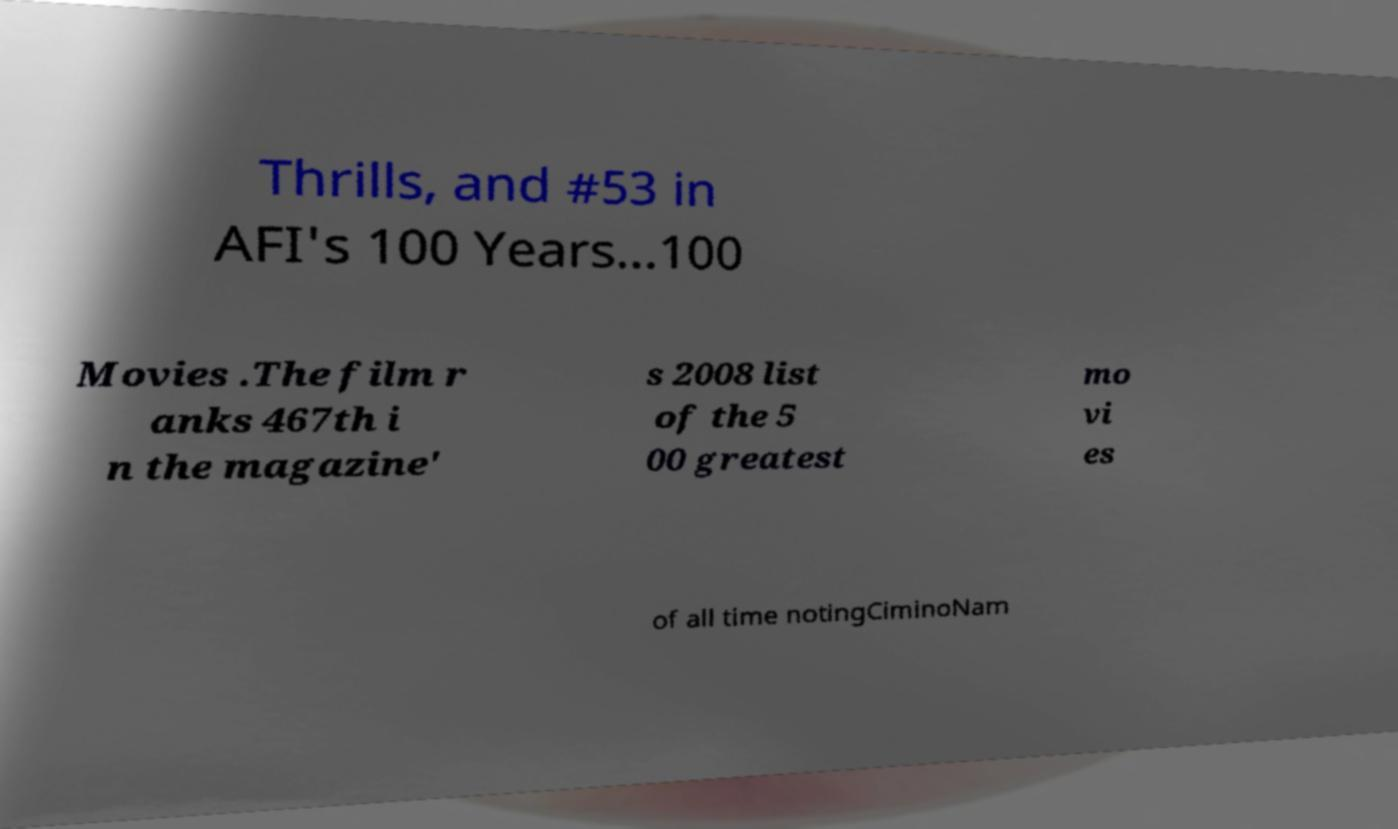Can you accurately transcribe the text from the provided image for me? Thrills, and #53 in AFI's 100 Years...100 Movies .The film r anks 467th i n the magazine' s 2008 list of the 5 00 greatest mo vi es of all time notingCiminoNam 